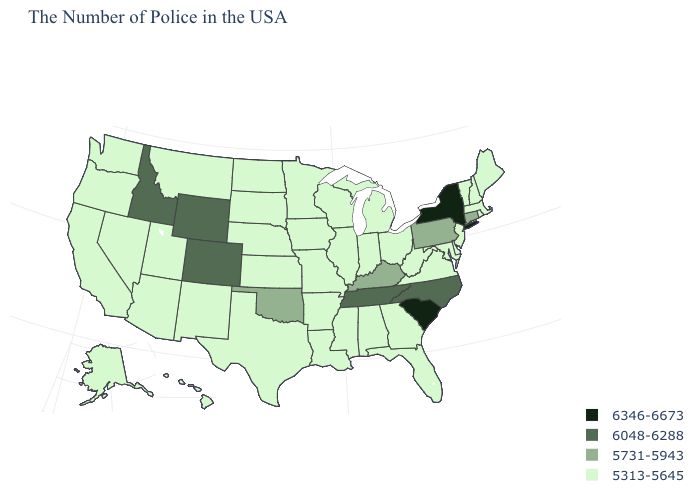Among the states that border Georgia , which have the lowest value?
Be succinct. Florida, Alabama. What is the value of Arizona?
Give a very brief answer. 5313-5645. Which states have the lowest value in the USA?
Answer briefly. Maine, Massachusetts, Rhode Island, New Hampshire, Vermont, New Jersey, Delaware, Maryland, Virginia, West Virginia, Ohio, Florida, Georgia, Michigan, Indiana, Alabama, Wisconsin, Illinois, Mississippi, Louisiana, Missouri, Arkansas, Minnesota, Iowa, Kansas, Nebraska, Texas, South Dakota, North Dakota, New Mexico, Utah, Montana, Arizona, Nevada, California, Washington, Oregon, Alaska, Hawaii. Name the states that have a value in the range 6048-6288?
Keep it brief. North Carolina, Tennessee, Wyoming, Colorado, Idaho. What is the value of Hawaii?
Give a very brief answer. 5313-5645. What is the lowest value in the USA?
Quick response, please. 5313-5645. Among the states that border Virginia , which have the lowest value?
Quick response, please. Maryland, West Virginia. Name the states that have a value in the range 6048-6288?
Write a very short answer. North Carolina, Tennessee, Wyoming, Colorado, Idaho. What is the value of Kansas?
Be succinct. 5313-5645. What is the value of Virginia?
Keep it brief. 5313-5645. Does Minnesota have the same value as West Virginia?
Concise answer only. Yes. Name the states that have a value in the range 6048-6288?
Quick response, please. North Carolina, Tennessee, Wyoming, Colorado, Idaho. Does the first symbol in the legend represent the smallest category?
Keep it brief. No. What is the lowest value in the USA?
Answer briefly. 5313-5645. 